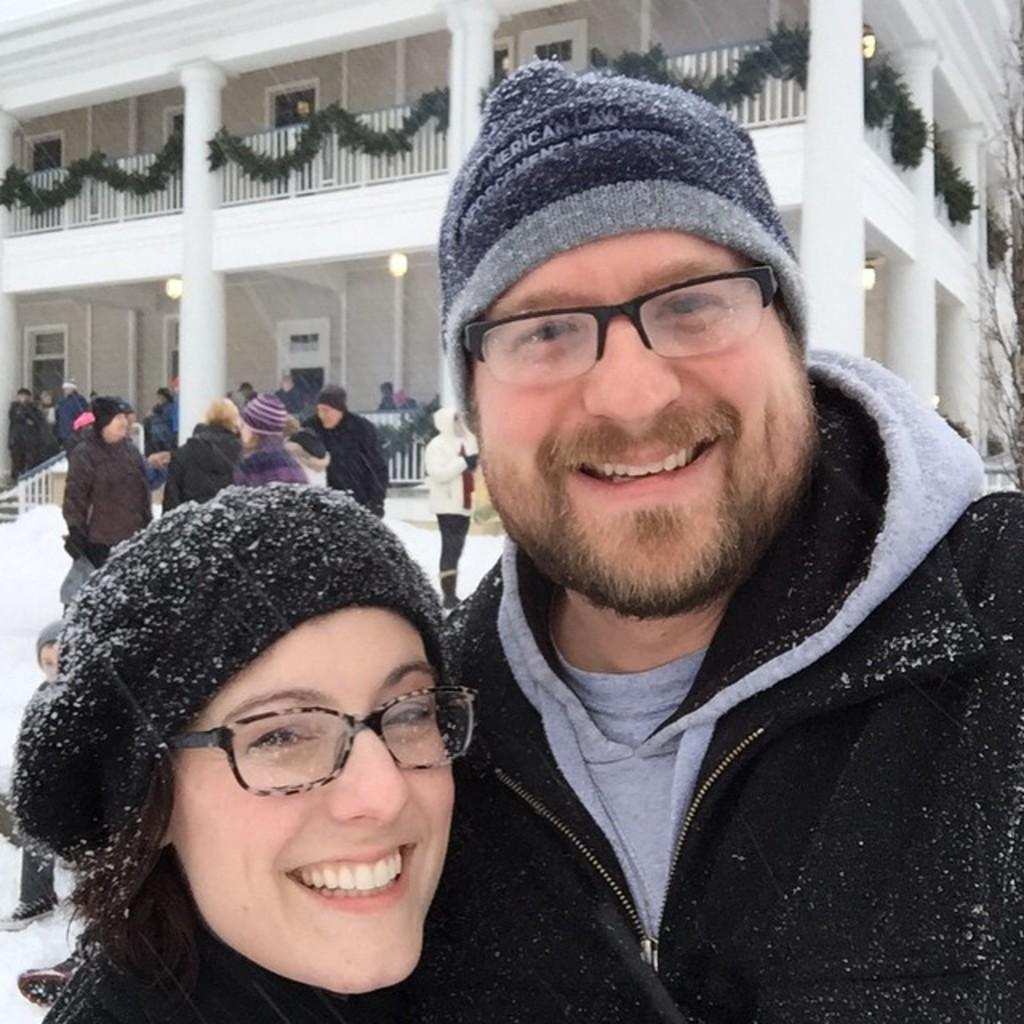Who or what can be seen in the image? There are people in the image. What type of structure is present in the image? There is a building in the image. What feature of the building is mentioned in the facts? The building has windows. What else is visible in the image besides the people and the building? There are lights and a fence in the image. What type of floor can be seen in the image? There is no specific mention of a floor in the image, as the focus is on the people, building, windows, lights, and fence. 